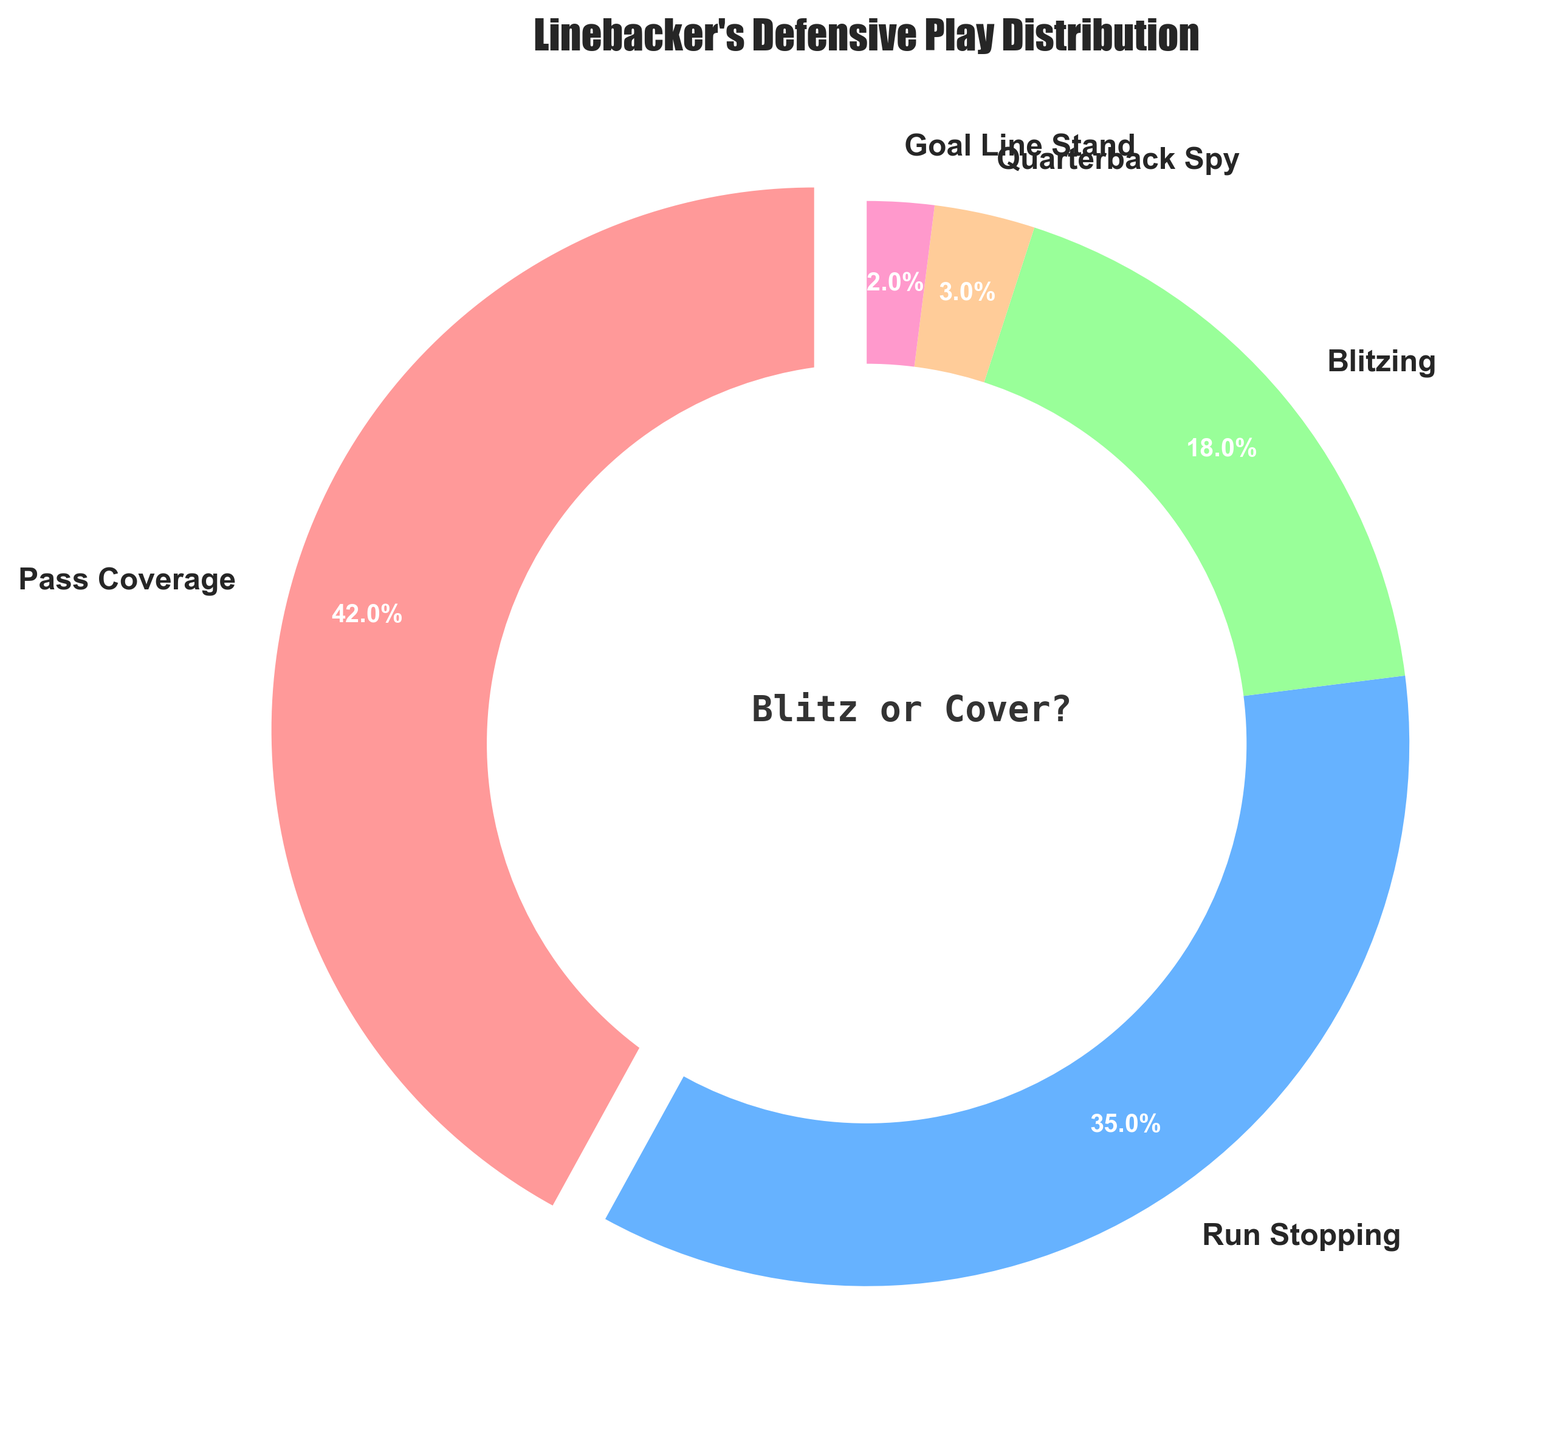What is the most common defensive play type for linebackers? The pie chart shows the distribution of defensive play types for linebackers. The largest section is Pass Coverage at 42%.
Answer: Pass Coverage Which play type has the smallest proportion in the chart? By observing the smallest slice in the pie chart, the smallest segment is Goal Line Stand at 2%.
Answer: Goal Line Stand How much more often do linebackers engage in Run Stopping compared to Blitzing? From the chart, Run Stopping is 35% and Blitzing is 18%. So, the difference is 35% - 18% = 17%.
Answer: 17% What percentage of the time are linebackers involved in either Pass Coverage or Run Stopping? The proportion for Pass Coverage is 42% and for Run Stopping is 35%. Therefore, combining them: 42% + 35% = 77%.
Answer: 77% How does the percentage of Blitzing compare to the combined percentage of Quarterback Spy and Goal Line Stand? Blitzing is 18%. The combined percentage for Quarterback Spy (3%) and Goal Line Stand (2%) is 3% + 2% = 5%, which is less than the Blitzing percentage.
Answer: Blitzing is more What is the median percentage value among all play types? To find the median, list the percentages in order: 2%, 3%, 18%, 35%, 42%. The middle value (median) is 18%.
Answer: 18% What proportion of the time are linebackers not involved in Pass Coverage? The percentage of Pass Coverage is 42%. Therefore, the percentage not involved in Pass Coverage is 100% - 42% = 58%.
Answer: 58% Which play types together make up less than 10% of the total distribution? The percentages for Quarterback Spy (3%) and Goal Line Stand (2%) together is 3% + 2% = 5%, which is less than 10%.
Answer: Quarterback Spy and Goal Line Stand If you sum the percentages of Blitzing, Quarterback Spy, and Goal Line Stand, what percentage do you get? Add together Blitzing (18%) + Quarterback Spy (3%) + Goal Line Stand (2%). This gives 18% + 3% + 2% = 23%.
Answer: 23% What color represents Run Stopping in the chart? Observing the pie chart and the color legend, Run Stopping is represented by a shade of blue.
Answer: Blue 